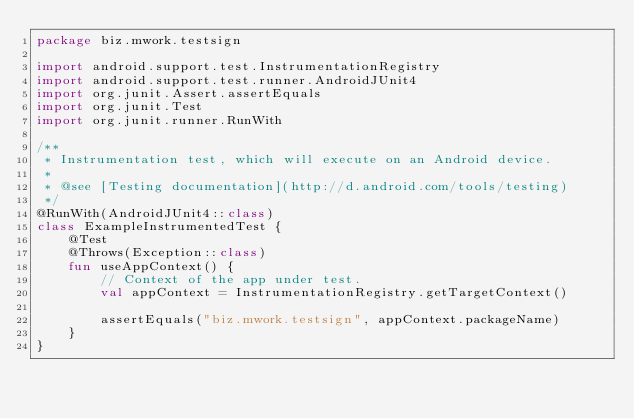<code> <loc_0><loc_0><loc_500><loc_500><_Kotlin_>package biz.mwork.testsign

import android.support.test.InstrumentationRegistry
import android.support.test.runner.AndroidJUnit4
import org.junit.Assert.assertEquals
import org.junit.Test
import org.junit.runner.RunWith

/**
 * Instrumentation test, which will execute on an Android device.
 *
 * @see [Testing documentation](http://d.android.com/tools/testing)
 */
@RunWith(AndroidJUnit4::class)
class ExampleInstrumentedTest {
    @Test
    @Throws(Exception::class)
    fun useAppContext() {
        // Context of the app under test.
        val appContext = InstrumentationRegistry.getTargetContext()

        assertEquals("biz.mwork.testsign", appContext.packageName)
    }
}
</code> 